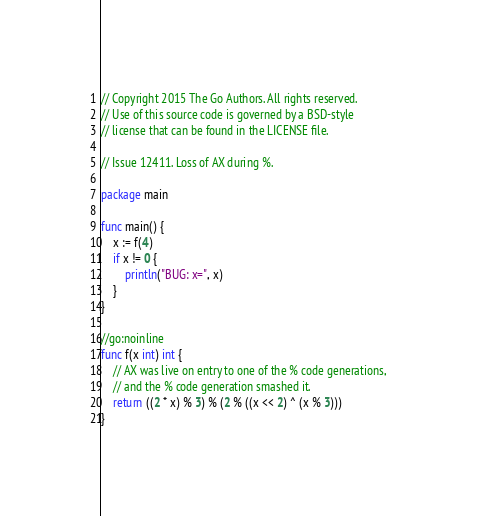Convert code to text. <code><loc_0><loc_0><loc_500><loc_500><_Go_>// Copyright 2015 The Go Authors. All rights reserved.
// Use of this source code is governed by a BSD-style
// license that can be found in the LICENSE file.

// Issue 12411. Loss of AX during %.

package main

func main() {
	x := f(4)
	if x != 0 {
		println("BUG: x=", x)
	}
}

//go:noinline
func f(x int) int {
	// AX was live on entry to one of the % code generations,
	// and the % code generation smashed it.
	return ((2 * x) % 3) % (2 % ((x << 2) ^ (x % 3)))
}
</code> 